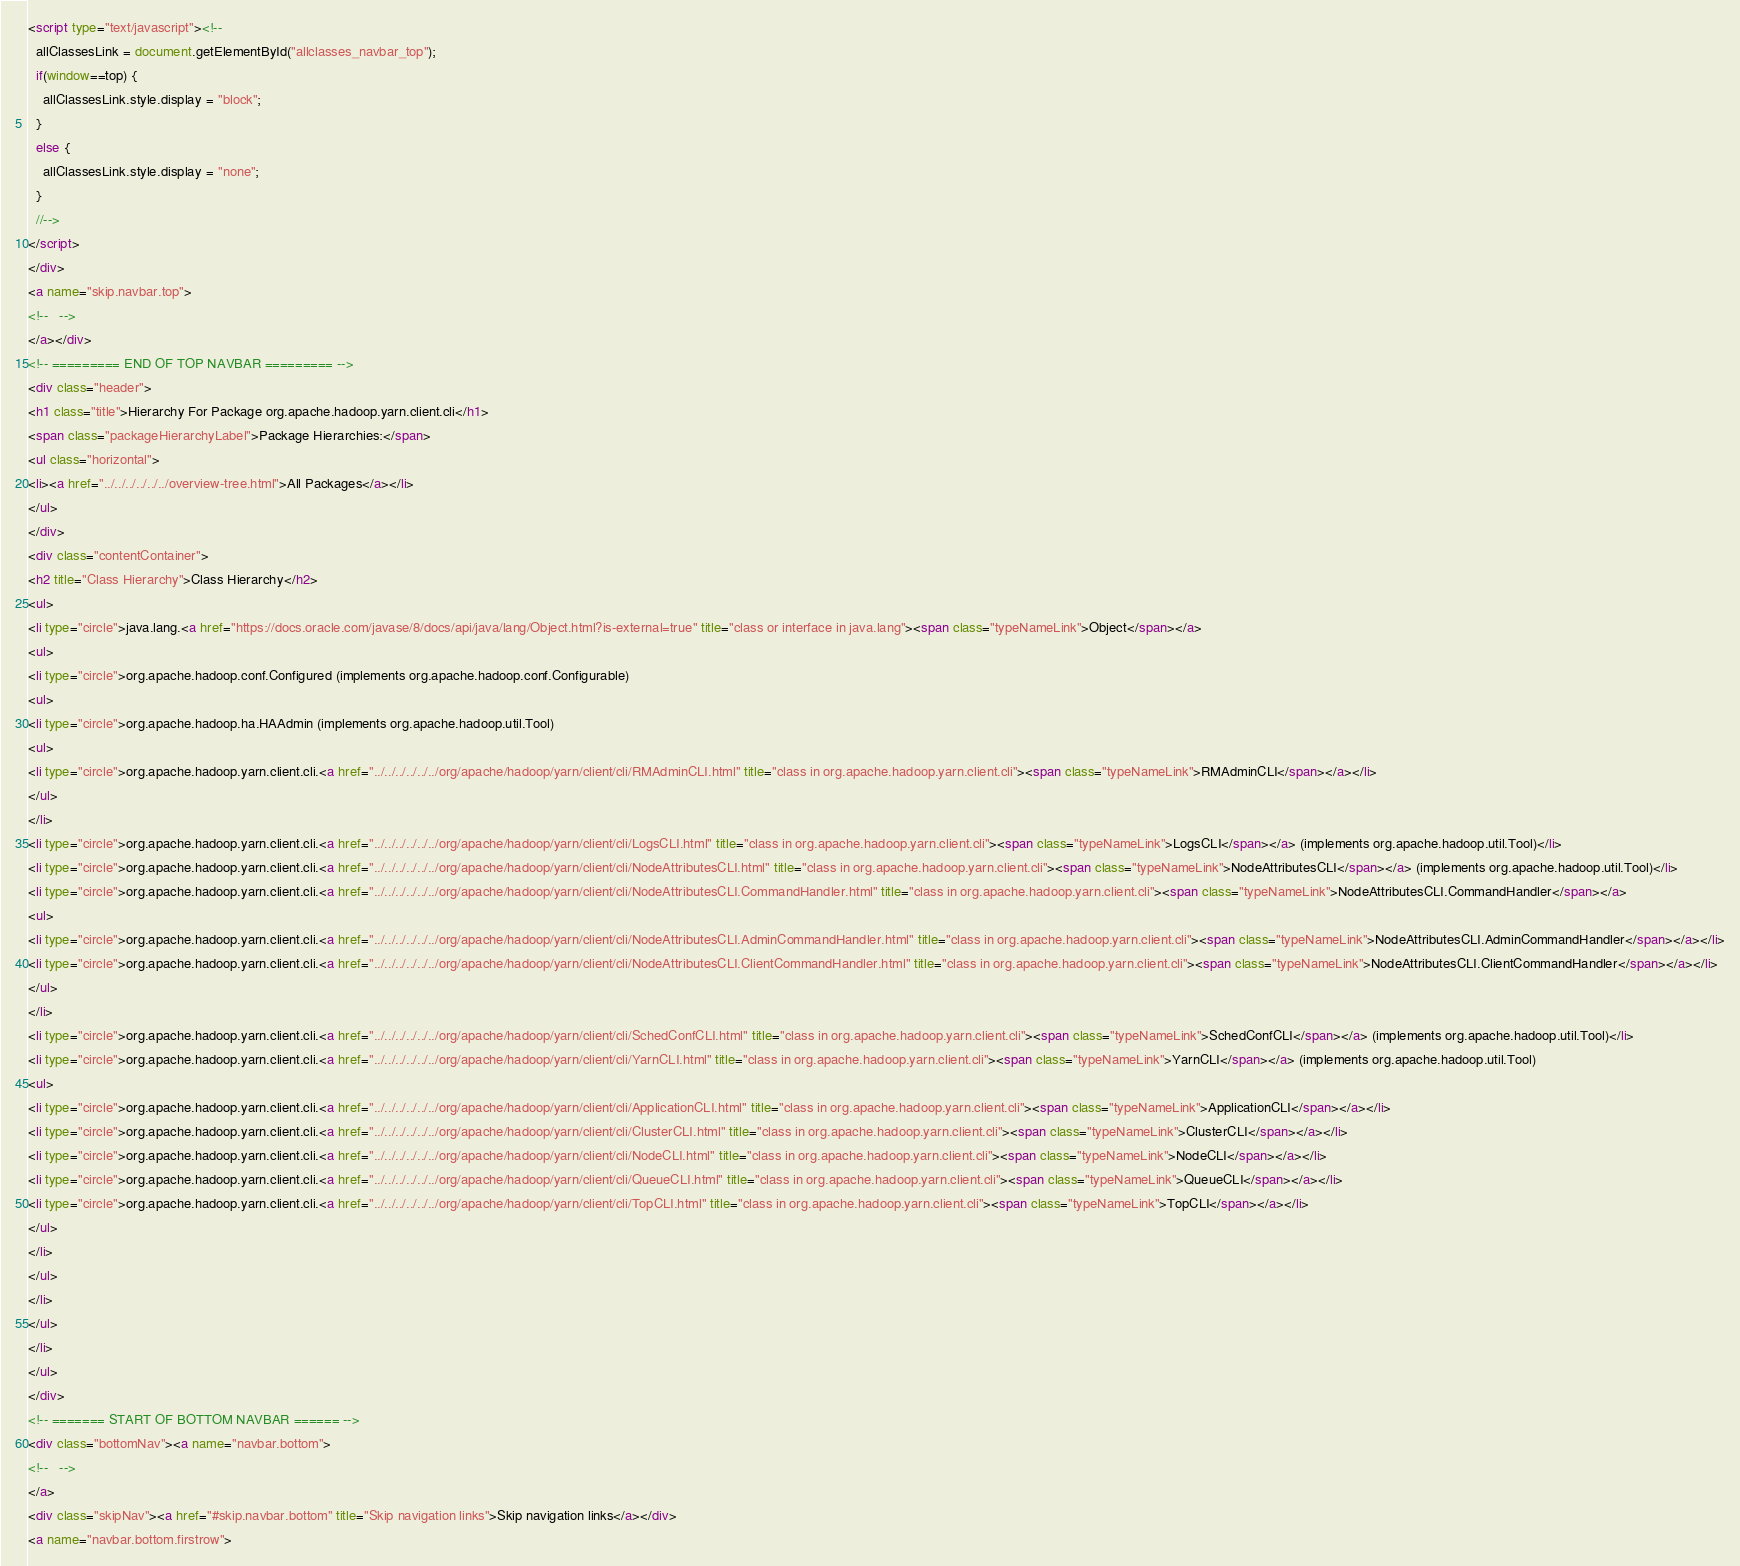<code> <loc_0><loc_0><loc_500><loc_500><_HTML_><script type="text/javascript"><!--
  allClassesLink = document.getElementById("allclasses_navbar_top");
  if(window==top) {
    allClassesLink.style.display = "block";
  }
  else {
    allClassesLink.style.display = "none";
  }
  //-->
</script>
</div>
<a name="skip.navbar.top">
<!--   -->
</a></div>
<!-- ========= END OF TOP NAVBAR ========= -->
<div class="header">
<h1 class="title">Hierarchy For Package org.apache.hadoop.yarn.client.cli</h1>
<span class="packageHierarchyLabel">Package Hierarchies:</span>
<ul class="horizontal">
<li><a href="../../../../../../overview-tree.html">All Packages</a></li>
</ul>
</div>
<div class="contentContainer">
<h2 title="Class Hierarchy">Class Hierarchy</h2>
<ul>
<li type="circle">java.lang.<a href="https://docs.oracle.com/javase/8/docs/api/java/lang/Object.html?is-external=true" title="class or interface in java.lang"><span class="typeNameLink">Object</span></a>
<ul>
<li type="circle">org.apache.hadoop.conf.Configured (implements org.apache.hadoop.conf.Configurable)
<ul>
<li type="circle">org.apache.hadoop.ha.HAAdmin (implements org.apache.hadoop.util.Tool)
<ul>
<li type="circle">org.apache.hadoop.yarn.client.cli.<a href="../../../../../../org/apache/hadoop/yarn/client/cli/RMAdminCLI.html" title="class in org.apache.hadoop.yarn.client.cli"><span class="typeNameLink">RMAdminCLI</span></a></li>
</ul>
</li>
<li type="circle">org.apache.hadoop.yarn.client.cli.<a href="../../../../../../org/apache/hadoop/yarn/client/cli/LogsCLI.html" title="class in org.apache.hadoop.yarn.client.cli"><span class="typeNameLink">LogsCLI</span></a> (implements org.apache.hadoop.util.Tool)</li>
<li type="circle">org.apache.hadoop.yarn.client.cli.<a href="../../../../../../org/apache/hadoop/yarn/client/cli/NodeAttributesCLI.html" title="class in org.apache.hadoop.yarn.client.cli"><span class="typeNameLink">NodeAttributesCLI</span></a> (implements org.apache.hadoop.util.Tool)</li>
<li type="circle">org.apache.hadoop.yarn.client.cli.<a href="../../../../../../org/apache/hadoop/yarn/client/cli/NodeAttributesCLI.CommandHandler.html" title="class in org.apache.hadoop.yarn.client.cli"><span class="typeNameLink">NodeAttributesCLI.CommandHandler</span></a>
<ul>
<li type="circle">org.apache.hadoop.yarn.client.cli.<a href="../../../../../../org/apache/hadoop/yarn/client/cli/NodeAttributesCLI.AdminCommandHandler.html" title="class in org.apache.hadoop.yarn.client.cli"><span class="typeNameLink">NodeAttributesCLI.AdminCommandHandler</span></a></li>
<li type="circle">org.apache.hadoop.yarn.client.cli.<a href="../../../../../../org/apache/hadoop/yarn/client/cli/NodeAttributesCLI.ClientCommandHandler.html" title="class in org.apache.hadoop.yarn.client.cli"><span class="typeNameLink">NodeAttributesCLI.ClientCommandHandler</span></a></li>
</ul>
</li>
<li type="circle">org.apache.hadoop.yarn.client.cli.<a href="../../../../../../org/apache/hadoop/yarn/client/cli/SchedConfCLI.html" title="class in org.apache.hadoop.yarn.client.cli"><span class="typeNameLink">SchedConfCLI</span></a> (implements org.apache.hadoop.util.Tool)</li>
<li type="circle">org.apache.hadoop.yarn.client.cli.<a href="../../../../../../org/apache/hadoop/yarn/client/cli/YarnCLI.html" title="class in org.apache.hadoop.yarn.client.cli"><span class="typeNameLink">YarnCLI</span></a> (implements org.apache.hadoop.util.Tool)
<ul>
<li type="circle">org.apache.hadoop.yarn.client.cli.<a href="../../../../../../org/apache/hadoop/yarn/client/cli/ApplicationCLI.html" title="class in org.apache.hadoop.yarn.client.cli"><span class="typeNameLink">ApplicationCLI</span></a></li>
<li type="circle">org.apache.hadoop.yarn.client.cli.<a href="../../../../../../org/apache/hadoop/yarn/client/cli/ClusterCLI.html" title="class in org.apache.hadoop.yarn.client.cli"><span class="typeNameLink">ClusterCLI</span></a></li>
<li type="circle">org.apache.hadoop.yarn.client.cli.<a href="../../../../../../org/apache/hadoop/yarn/client/cli/NodeCLI.html" title="class in org.apache.hadoop.yarn.client.cli"><span class="typeNameLink">NodeCLI</span></a></li>
<li type="circle">org.apache.hadoop.yarn.client.cli.<a href="../../../../../../org/apache/hadoop/yarn/client/cli/QueueCLI.html" title="class in org.apache.hadoop.yarn.client.cli"><span class="typeNameLink">QueueCLI</span></a></li>
<li type="circle">org.apache.hadoop.yarn.client.cli.<a href="../../../../../../org/apache/hadoop/yarn/client/cli/TopCLI.html" title="class in org.apache.hadoop.yarn.client.cli"><span class="typeNameLink">TopCLI</span></a></li>
</ul>
</li>
</ul>
</li>
</ul>
</li>
</ul>
</div>
<!-- ======= START OF BOTTOM NAVBAR ====== -->
<div class="bottomNav"><a name="navbar.bottom">
<!--   -->
</a>
<div class="skipNav"><a href="#skip.navbar.bottom" title="Skip navigation links">Skip navigation links</a></div>
<a name="navbar.bottom.firstrow"></code> 